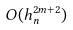<formula> <loc_0><loc_0><loc_500><loc_500>O ( h _ { n } ^ { 2 m + 2 } )</formula> 